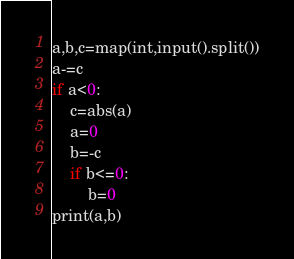<code> <loc_0><loc_0><loc_500><loc_500><_Python_>a,b,c=map(int,input().split())
a-=c
if a<0:
    c=abs(a)
    a=0
    b=-c
    if b<=0:
        b=0
print(a,b)</code> 